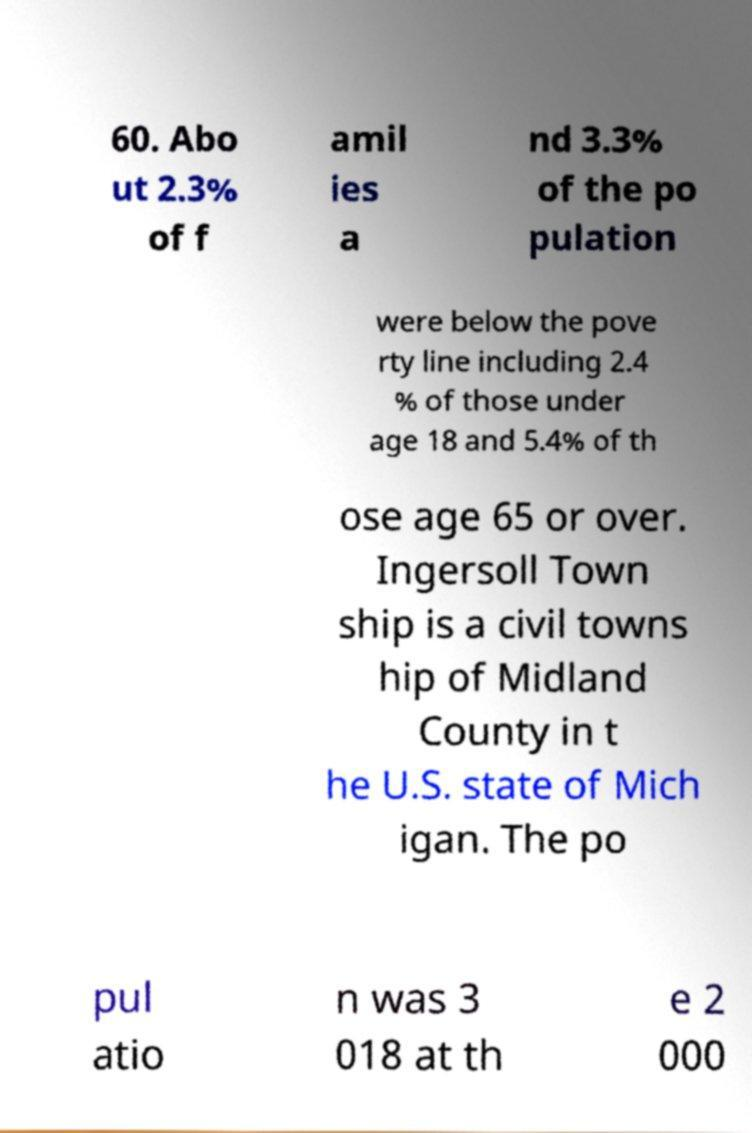Could you extract and type out the text from this image? 60. Abo ut 2.3% of f amil ies a nd 3.3% of the po pulation were below the pove rty line including 2.4 % of those under age 18 and 5.4% of th ose age 65 or over. Ingersoll Town ship is a civil towns hip of Midland County in t he U.S. state of Mich igan. The po pul atio n was 3 018 at th e 2 000 